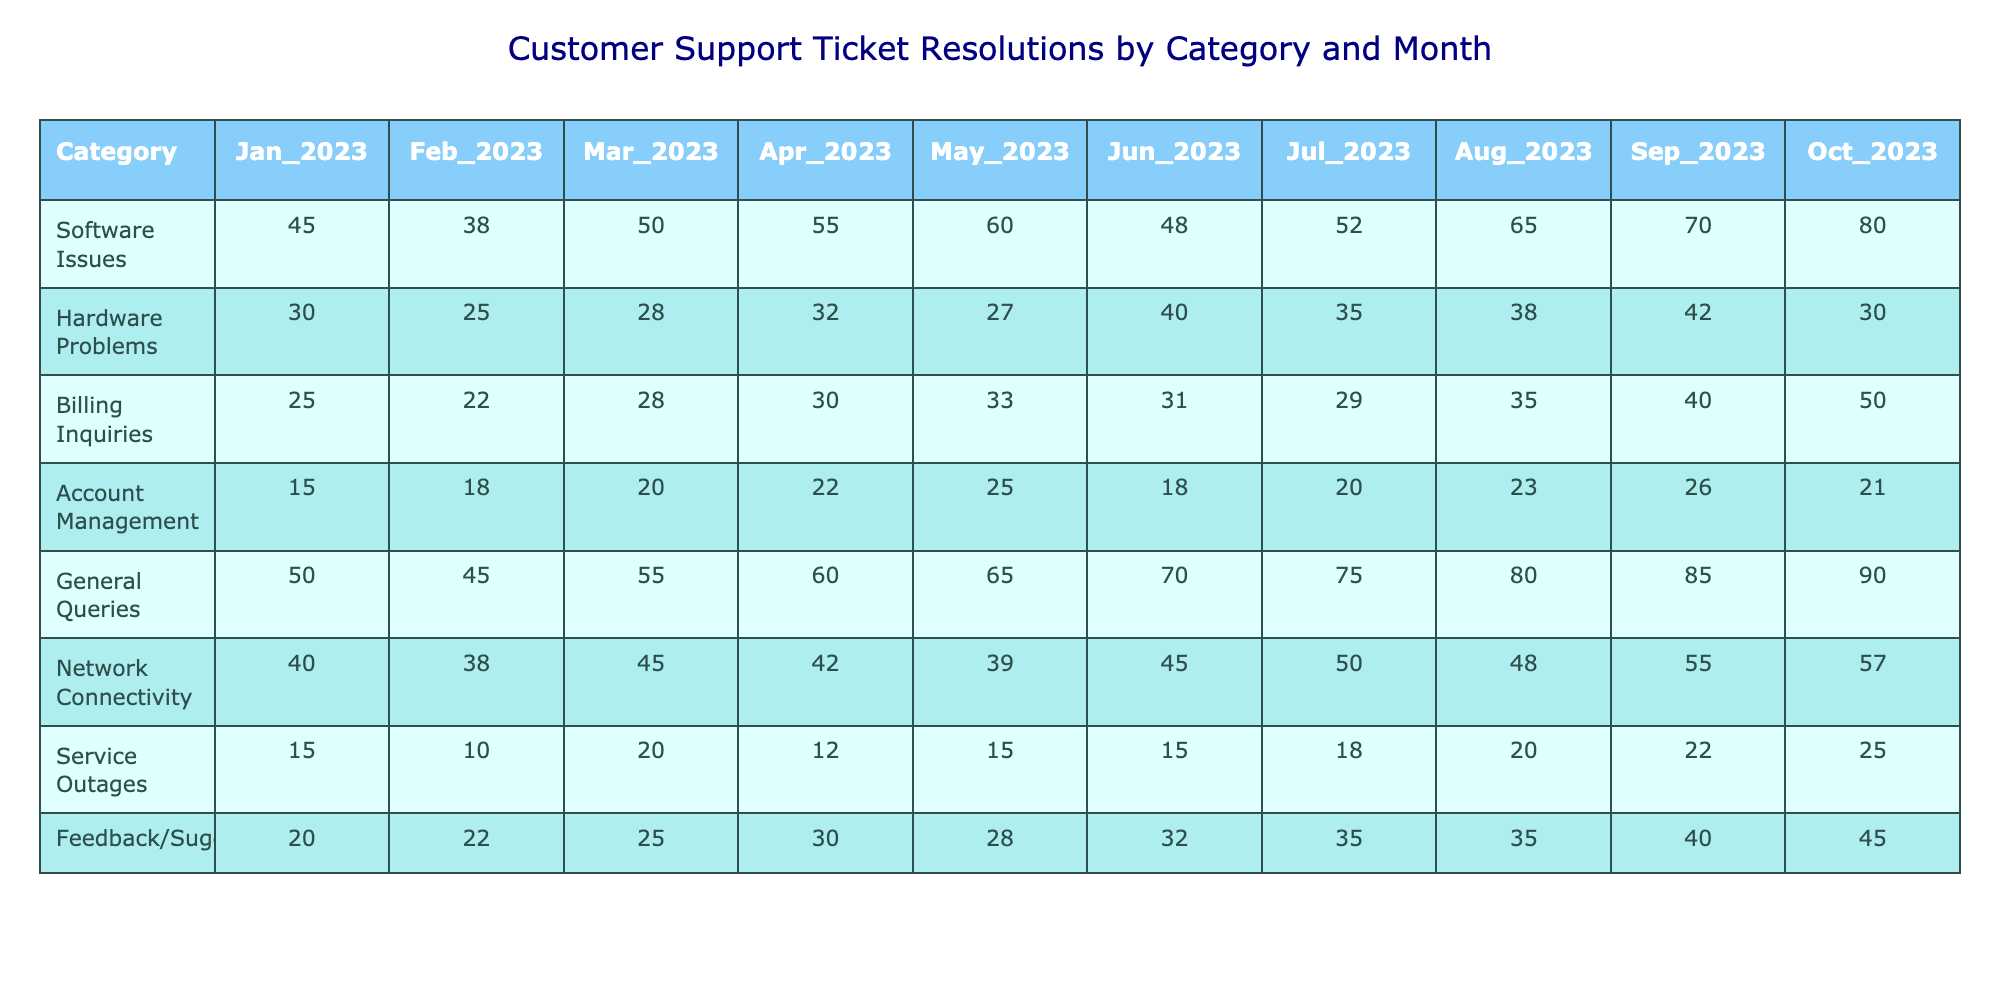What was the highest number of ticket resolutions in a single month for Software Issues? Looking at the Software Issues row, the highest value is 80, which occurs in October 2023.
Answer: 80 What was the lowest number of ticket resolutions for Service Outages? The lowest number for Service Outages is 10, which occurs in February 2023.
Answer: 10 Which category had the most ticket resolutions in August 2023? Checking the August 2023 column, General Queries had the highest resolutions with a value of 80.
Answer: General Queries What is the total number of resolutions for Hardware Problems over the first half of the year? Adding the values from January to June for Hardware Problems (30 + 25 + 28 + 32 + 27 + 40) gives a total of 182.
Answer: 182 Did Billing Inquiries see an increase or decrease from January 2023 to October 2023? The value for Billing Inquiries increased from 25 in January to 50 in October, indicating an increase.
Answer: Increase What was the average number of resolutions across all categories for May 2023? The values for each category in May are: Software Issues (60), Hardware Problems (27), Billing Inquiries (33), Account Management (25), General Queries (65), Network Connectivity (39), Service Outages (15), and Feedback/Suggestions (28). The sum is 60 + 27 + 33 + 25 + 65 + 39 + 15 + 28 = 292. There are 8 categories, so the average is 292 / 8 = 36.5.
Answer: 36.5 Which month had the highest resolution total across all categories? Summing the totals for each month: January (30 + 45 + 25 + 15 + 50 + 40 + 15 + 20 = 230), February (38 + 25 + 22 + 18 + 45 + 38 + 10 + 22 = 218), March (50 + 28 + 28 + 20 + 55 + 45 + 20 + 25 = 271), April (55 + 32 + 30 + 22 + 60 + 42 + 12 + 30 = 333), May (60 + 27 + 33 + 25 + 65 + 39 + 15 + 28 = 292), June (48 + 40 + 31 + 18 + 70 + 45 + 15 + 32 = 319), July (52 + 35 + 29 + 20 + 75 + 50 + 18 + 35 =  364), August (65 + 38 + 35 + 23 + 80 + 48 + 20 + 35 = 364), September (70 + 42 + 40 + 26 + 85 + 55 + 22 + 40 = 400), October (80 + 30 + 50 + 21 + 90 + 57 + 25 + 45 = 398). The highest total is 400 in September 2023.
Answer: September 2023 Is the trend for General Queries generally upward over the months? The values for General Queries are: 50, 45, 55, 60, 65, 70, 75, 80, 85, 90, showing a consistent increase each month.
Answer: Yes What is the percentage increase in ticket resolutions for Network Connectivity from January to October 2023? The value for Network Connectivity in January is 40 and in October is 57. The increase is 57 - 40 = 17. To find the percentage increase: (17 / 40) * 100 = 42.5%.
Answer: 42.5% 